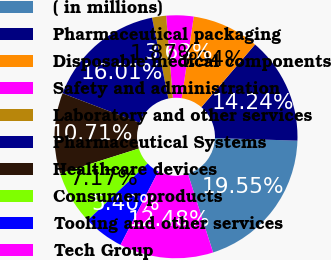<chart> <loc_0><loc_0><loc_500><loc_500><pie_chart><fcel>( in millions)<fcel>Pharmaceutical packaging<fcel>Disposable medical components<fcel>Safety and administration<fcel>Laboratory and other services<fcel>Pharmaceutical Systems<fcel>Healthcare devices<fcel>Consumer products<fcel>Tooling and other services<fcel>Tech Group<nl><fcel>19.55%<fcel>14.24%<fcel>8.94%<fcel>3.63%<fcel>1.87%<fcel>16.01%<fcel>10.71%<fcel>7.17%<fcel>5.4%<fcel>12.48%<nl></chart> 